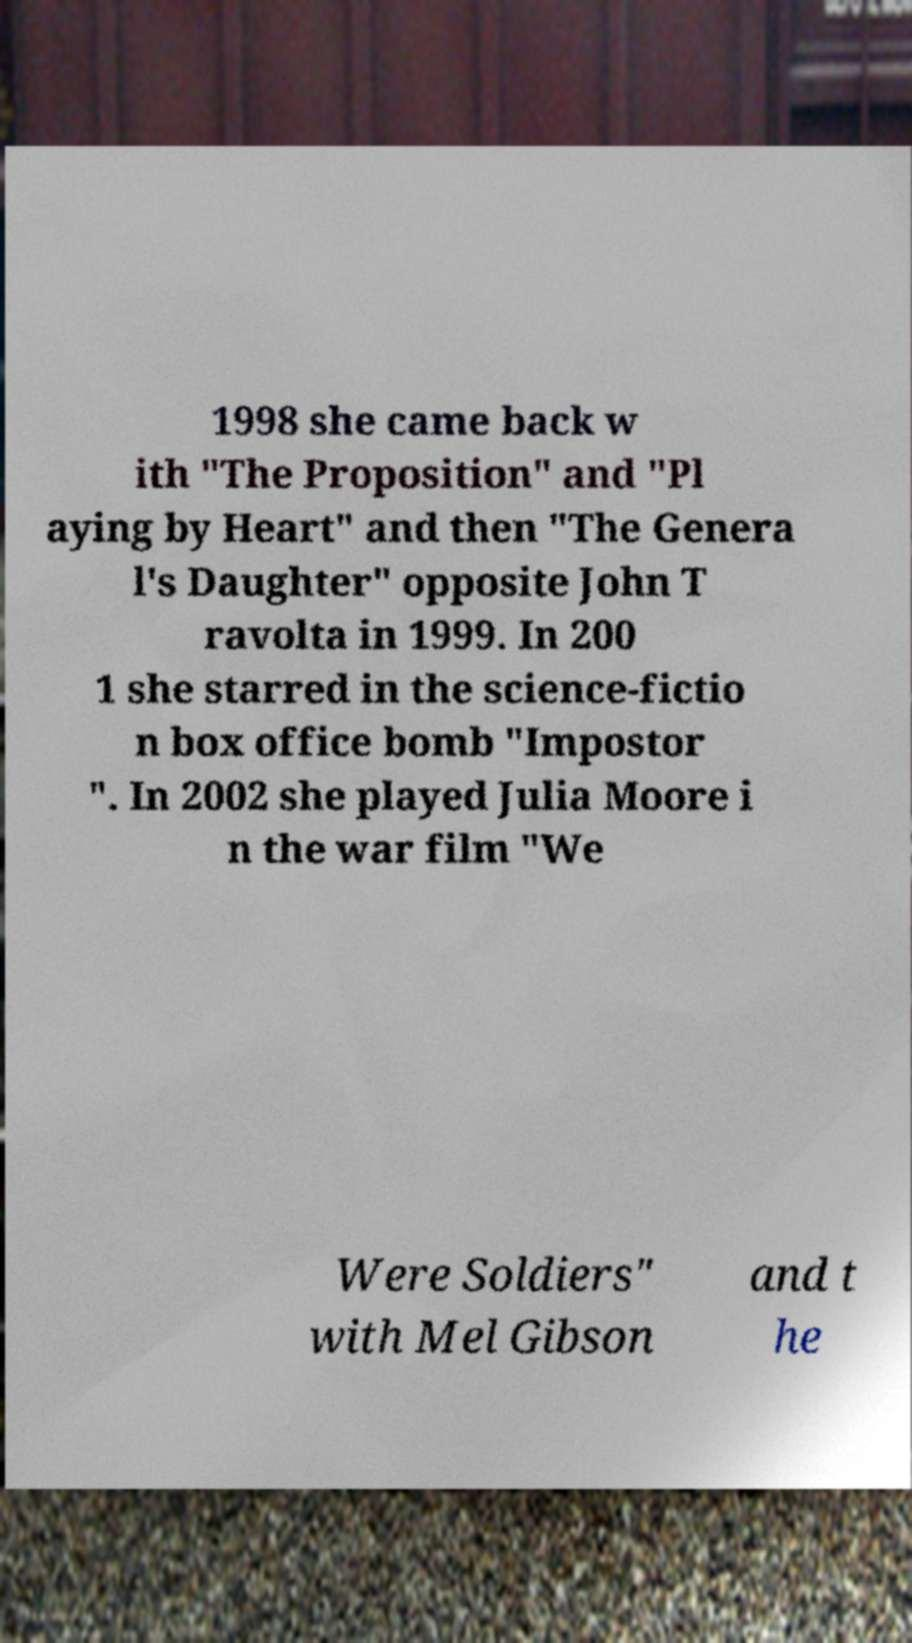For documentation purposes, I need the text within this image transcribed. Could you provide that? 1998 she came back w ith "The Proposition" and "Pl aying by Heart" and then "The Genera l's Daughter" opposite John T ravolta in 1999. In 200 1 she starred in the science-fictio n box office bomb "Impostor ". In 2002 she played Julia Moore i n the war film "We Were Soldiers" with Mel Gibson and t he 